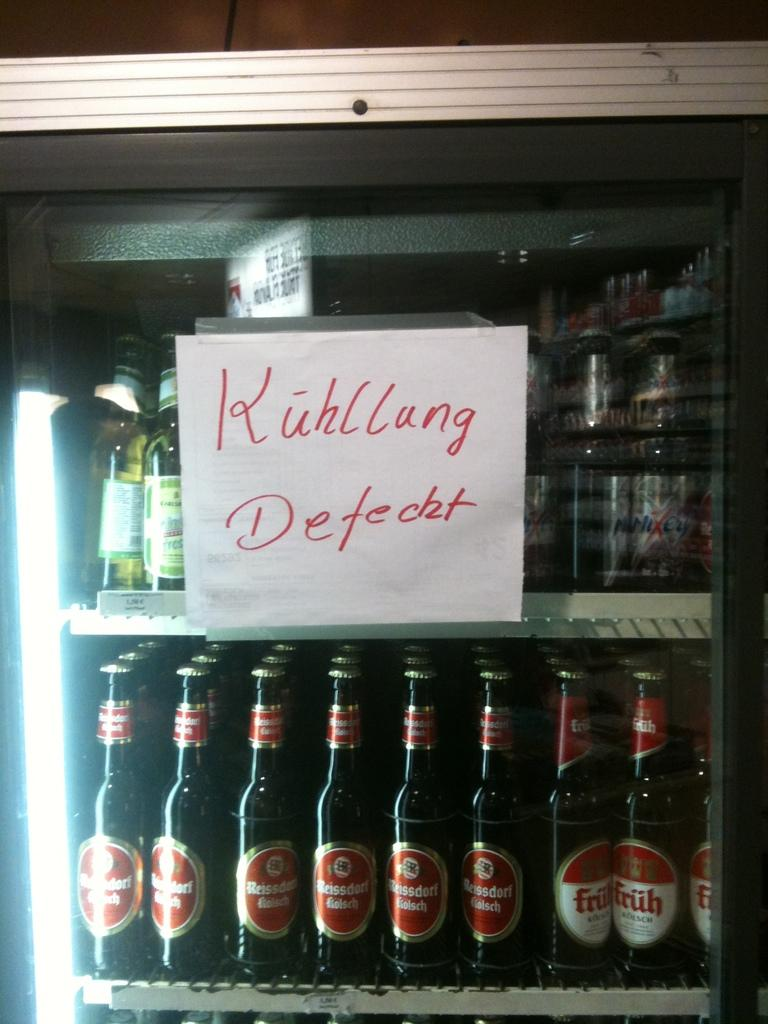Provide a one-sentence caption for the provided image. Mini fridge full of beers on top and bottom rack. 